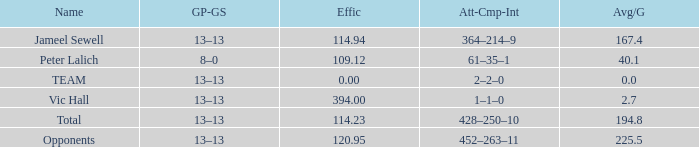What overall amount is associated with an avg/g featuring a 1-1-0 att-cmp-int and an efficiency above 394? 0.0. 